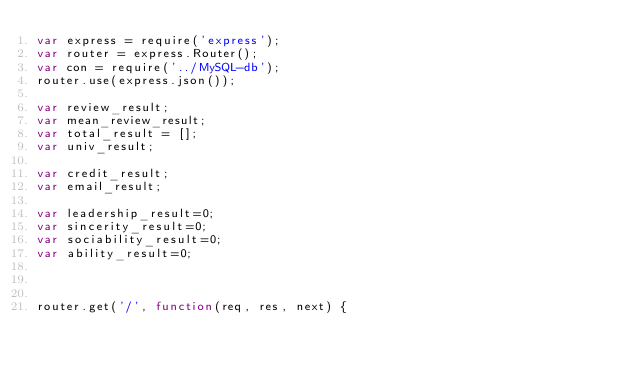Convert code to text. <code><loc_0><loc_0><loc_500><loc_500><_JavaScript_>var express = require('express');
var router = express.Router();
var con = require('../MySQL-db');
router.use(express.json());

var review_result;
var mean_review_result;
var total_result = [];
var univ_result;

var credit_result;
var email_result;

var leadership_result=0;
var sincerity_result=0;
var sociability_result=0;
var ability_result=0;



router.get('/', function(req, res, next) {</code> 